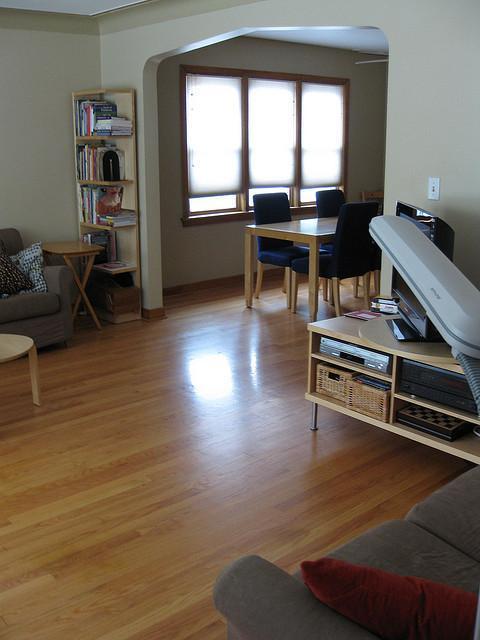How many doors lead to the room?
Give a very brief answer. 1. How many pillows on the sofa?
Give a very brief answer. 1. How many chairs are there?
Give a very brief answer. 3. How many sinks are shown?
Give a very brief answer. 0. 